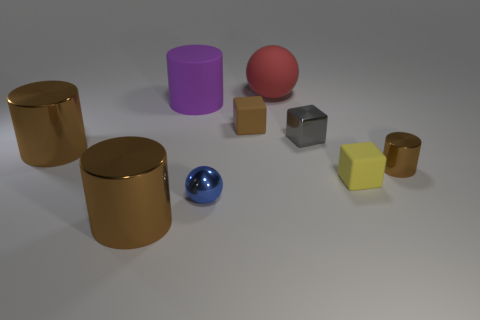Subtract all brown cylinders. How many were subtracted if there are1brown cylinders left? 2 Subtract all yellow balls. How many brown cylinders are left? 3 Subtract all blue cylinders. Subtract all brown cubes. How many cylinders are left? 4 Add 1 big yellow shiny objects. How many objects exist? 10 Subtract all cubes. How many objects are left? 6 Subtract 0 green spheres. How many objects are left? 9 Subtract all red balls. Subtract all large green blocks. How many objects are left? 8 Add 3 large purple things. How many large purple things are left? 4 Add 8 brown metallic cubes. How many brown metallic cubes exist? 8 